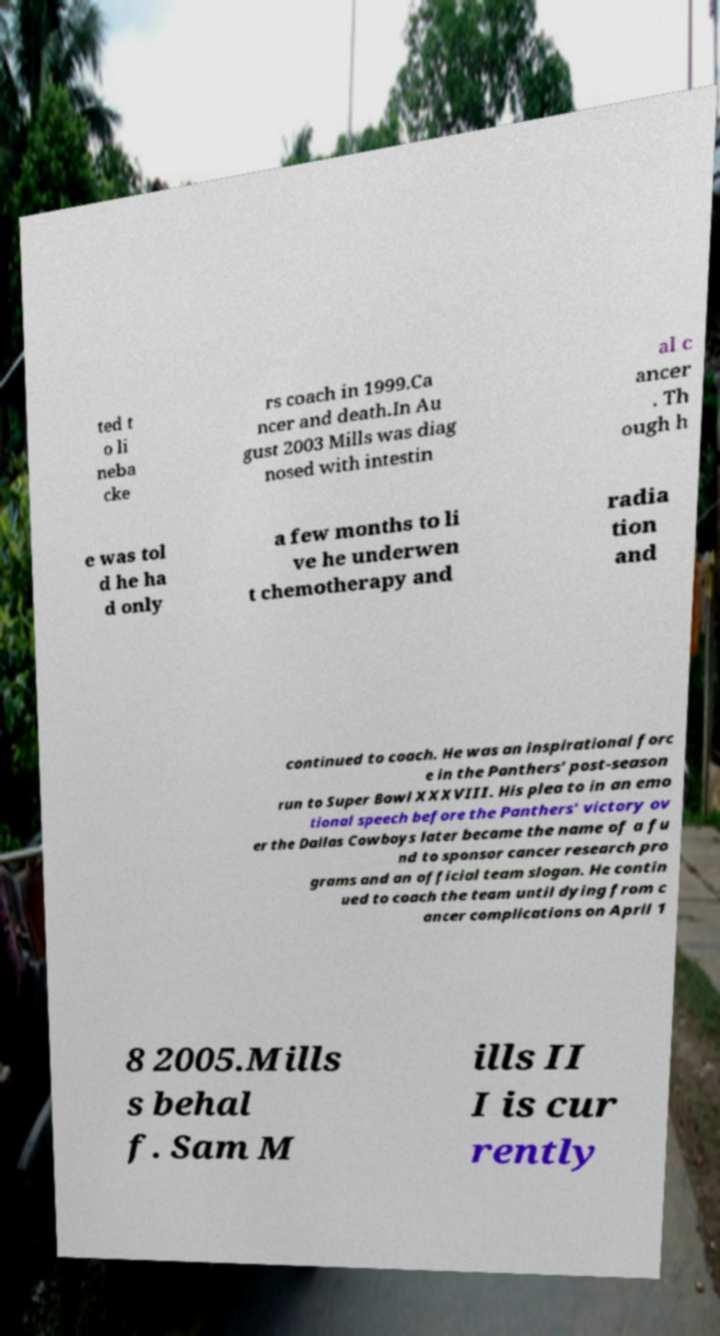I need the written content from this picture converted into text. Can you do that? ted t o li neba cke rs coach in 1999.Ca ncer and death.In Au gust 2003 Mills was diag nosed with intestin al c ancer . Th ough h e was tol d he ha d only a few months to li ve he underwen t chemotherapy and radia tion and continued to coach. He was an inspirational forc e in the Panthers’ post-season run to Super Bowl XXXVIII. His plea to in an emo tional speech before the Panthers' victory ov er the Dallas Cowboys later became the name of a fu nd to sponsor cancer research pro grams and an official team slogan. He contin ued to coach the team until dying from c ancer complications on April 1 8 2005.Mills s behal f. Sam M ills II I is cur rently 